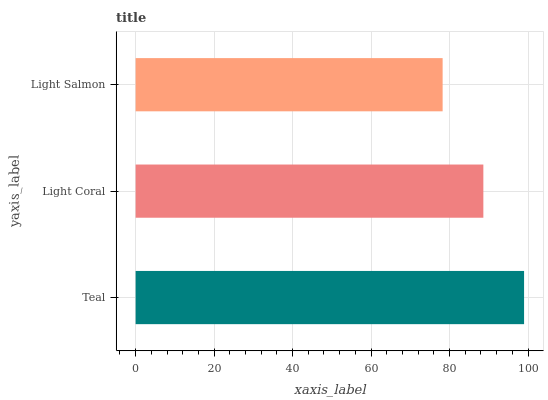Is Light Salmon the minimum?
Answer yes or no. Yes. Is Teal the maximum?
Answer yes or no. Yes. Is Light Coral the minimum?
Answer yes or no. No. Is Light Coral the maximum?
Answer yes or no. No. Is Teal greater than Light Coral?
Answer yes or no. Yes. Is Light Coral less than Teal?
Answer yes or no. Yes. Is Light Coral greater than Teal?
Answer yes or no. No. Is Teal less than Light Coral?
Answer yes or no. No. Is Light Coral the high median?
Answer yes or no. Yes. Is Light Coral the low median?
Answer yes or no. Yes. Is Light Salmon the high median?
Answer yes or no. No. Is Teal the low median?
Answer yes or no. No. 